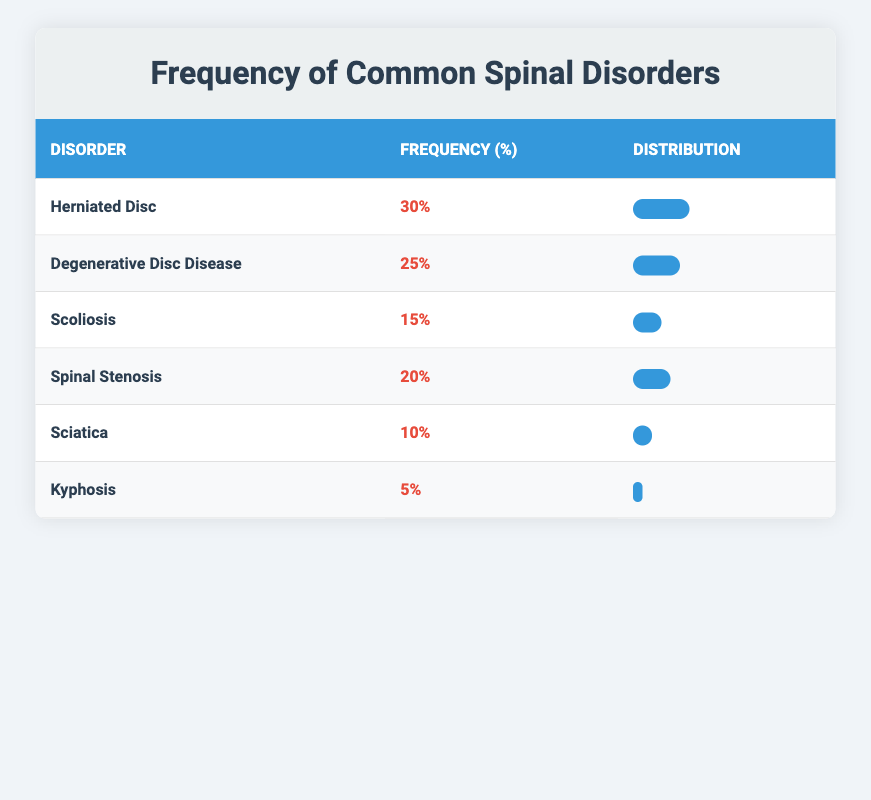What is the frequency of Herniated Disc among patients? According to the table, the frequency of Herniated Disc is directly provided in the 'Frequency' column. It shows a frequency of 30%.
Answer: 30% Which spinal disorder has the lowest frequency? Looking at the 'Frequency' column, the disorder with the lowest frequency is Kyphosis, which is listed with a frequency of 5%.
Answer: Kyphosis What is the sum of the frequencies for Degenerative Disc Disease and Spinal Stenosis? To find the sum, we take the frequency for Degenerative Disc Disease (25%) and for Spinal Stenosis (20%). Adding these gives us 25 + 20 = 45%.
Answer: 45% Is Scoliosis more common than Sciatica? By comparing the frequencies from the table, Scoliosis shows a frequency of 15% while Sciatica shows 10%. Since 15% is greater than 10%, the statement is true.
Answer: Yes What is the average frequency of the spinal disorders listed? To calculate the average, we sum the frequencies of all six disorders: 30 + 25 + 15 + 20 + 10 + 5 = 105%. Then we divide that total (105%) by the number of disorders (6). Therefore, the average frequency is 105 / 6 = 17.5%.
Answer: 17.5% How many disorders have a frequency of 15% or more? The disorders with a frequency of 15% or more are Herniated Disc (30%), Degenerative Disc Disease (25%), Scoliosis (15%), and Spinal Stenosis (20%). Counting these gives us four disorders.
Answer: 4 Which disorder has a frequency greater than Sciatica? Sciatica has a frequency of 10%. Checking the table, Herniated Disc (30%), Degenerative Disc Disease (25%), Scoliosis (15%), and Spinal Stenosis (20%) all have frequencies greater than 10%. Therefore, there are four disorders that meet this condition.
Answer: 4 What percentage of patients have either Herniated Disc or Degenerative Disc Disease? Adding the frequencies of these two disorders: Herniated Disc (30%) and Degenerative Disc Disease (25%) yields 30 + 25 = 55%. Therefore, 55% of patients have either one of these disorders.
Answer: 55% 